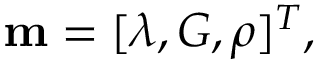Convert formula to latex. <formula><loc_0><loc_0><loc_500><loc_500>m = [ \lambda , G , \rho ] ^ { T } ,</formula> 